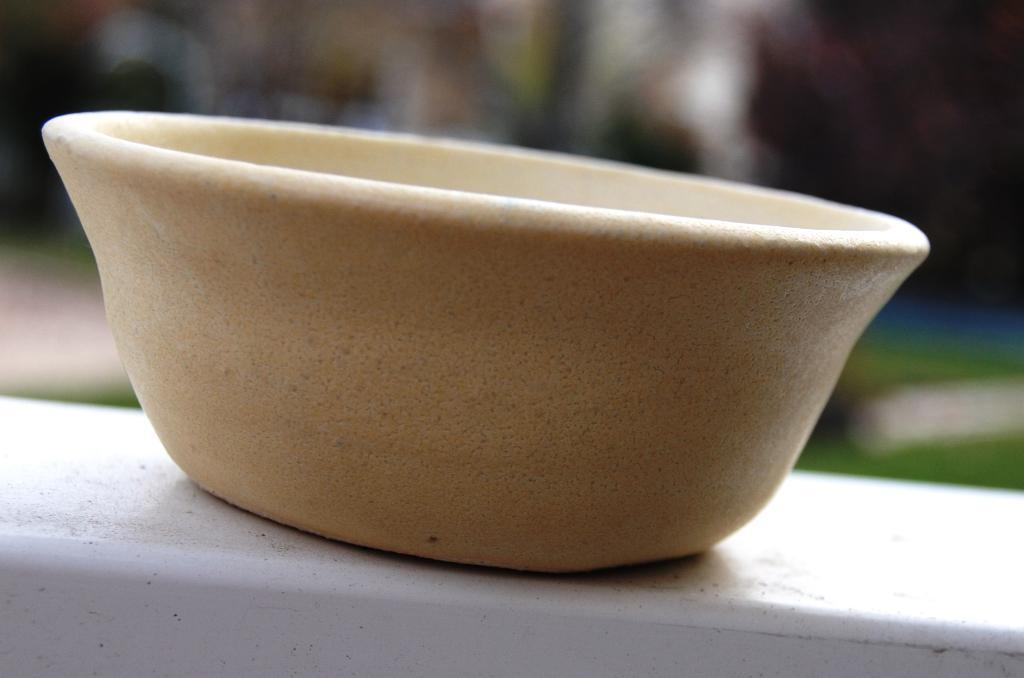What is the main object in the image? There is a bowl in the image. Where is the bowl placed? The bowl is on a wooden block. What type of treatment is the silk receiving in the image? There is no silk or treatment present in the image. 